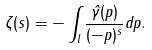Convert formula to latex. <formula><loc_0><loc_0><loc_500><loc_500>\zeta ( s ) = - \int _ { l } \frac { \hat { \gamma } ( p ) } { ( - p ) ^ { s } } d p .</formula> 